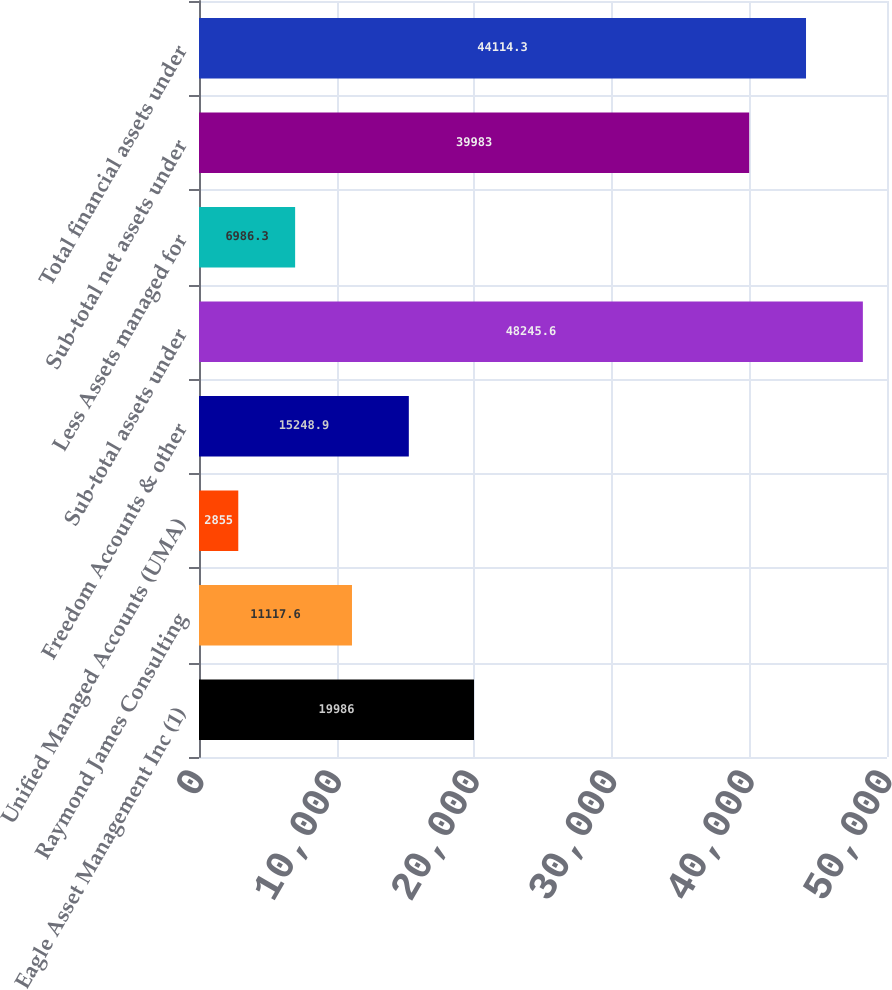Convert chart to OTSL. <chart><loc_0><loc_0><loc_500><loc_500><bar_chart><fcel>Eagle Asset Management Inc (1)<fcel>Raymond James Consulting<fcel>Unified Managed Accounts (UMA)<fcel>Freedom Accounts & other<fcel>Sub-total assets under<fcel>Less Assets managed for<fcel>Sub-total net assets under<fcel>Total financial assets under<nl><fcel>19986<fcel>11117.6<fcel>2855<fcel>15248.9<fcel>48245.6<fcel>6986.3<fcel>39983<fcel>44114.3<nl></chart> 